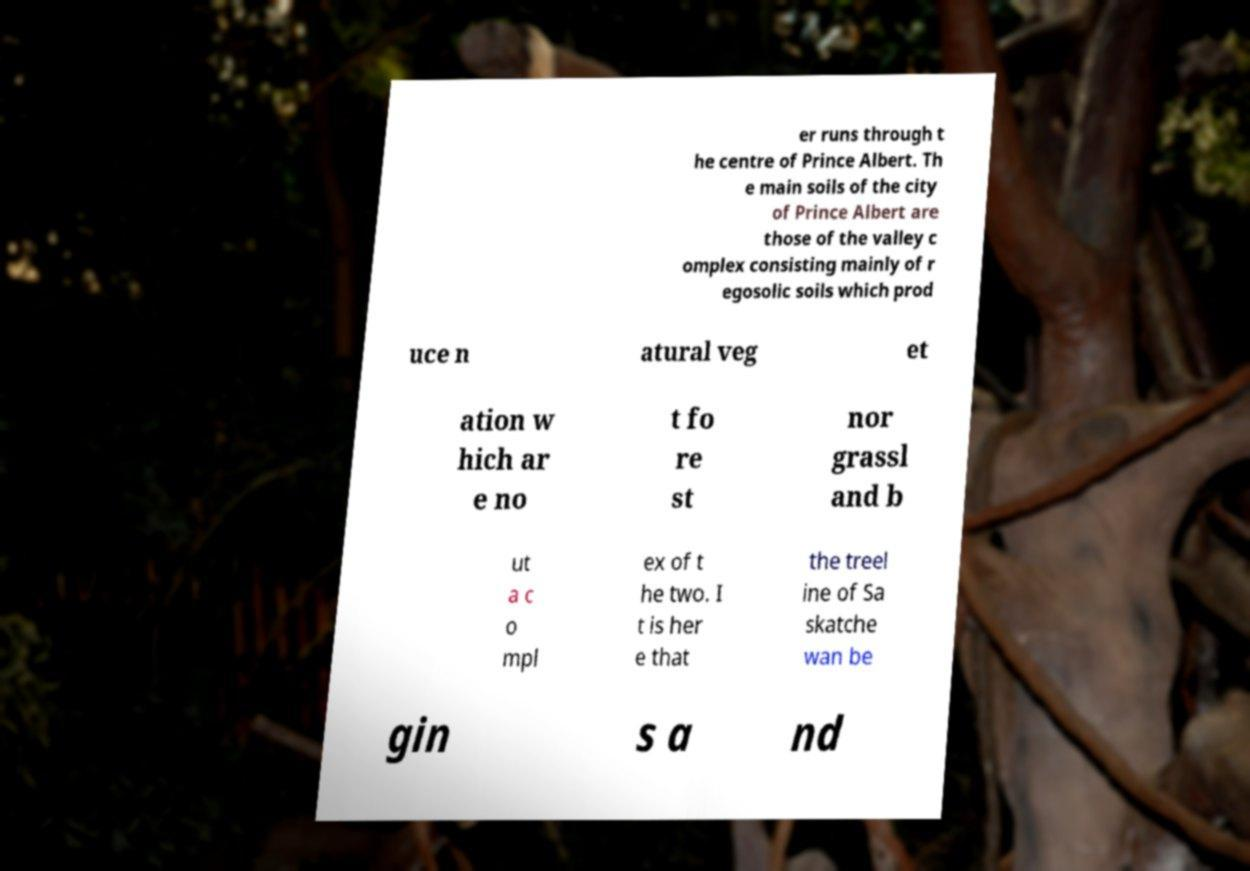For documentation purposes, I need the text within this image transcribed. Could you provide that? er runs through t he centre of Prince Albert. Th e main soils of the city of Prince Albert are those of the valley c omplex consisting mainly of r egosolic soils which prod uce n atural veg et ation w hich ar e no t fo re st nor grassl and b ut a c o mpl ex of t he two. I t is her e that the treel ine of Sa skatche wan be gin s a nd 